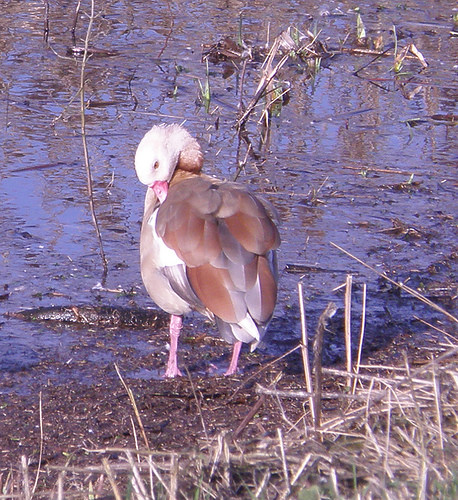<image>
Is there a bird behind the water? No. The bird is not behind the water. From this viewpoint, the bird appears to be positioned elsewhere in the scene. Where is the bird in relation to the grass? Is it in the grass? No. The bird is not contained within the grass. These objects have a different spatial relationship. 